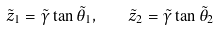<formula> <loc_0><loc_0><loc_500><loc_500>\tilde { z } _ { 1 } = \tilde { \gamma } \tan { \tilde { \theta } _ { 1 } } , \quad \tilde { z } _ { 2 } = \tilde { \gamma } \tan { \tilde { \theta } _ { 2 } }</formula> 